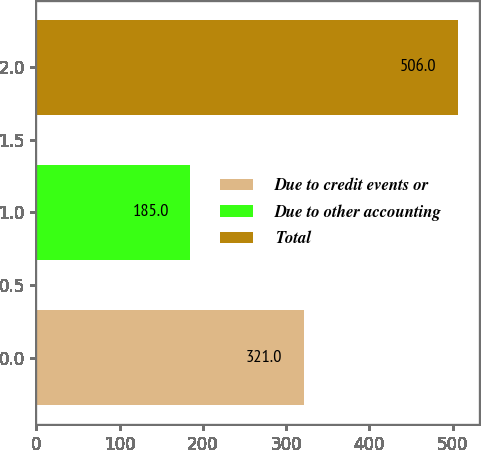Convert chart. <chart><loc_0><loc_0><loc_500><loc_500><bar_chart><fcel>Due to credit events or<fcel>Due to other accounting<fcel>Total<nl><fcel>321<fcel>185<fcel>506<nl></chart> 